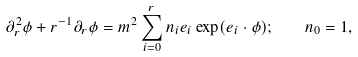Convert formula to latex. <formula><loc_0><loc_0><loc_500><loc_500>\partial _ { r } ^ { 2 } \phi + r ^ { - 1 } \partial _ { r } \phi = m ^ { 2 } \sum _ { i = 0 } ^ { r } n _ { i } e _ { i } \exp ( e _ { i } \cdot \phi ) ; \quad n _ { 0 } = 1 ,</formula> 